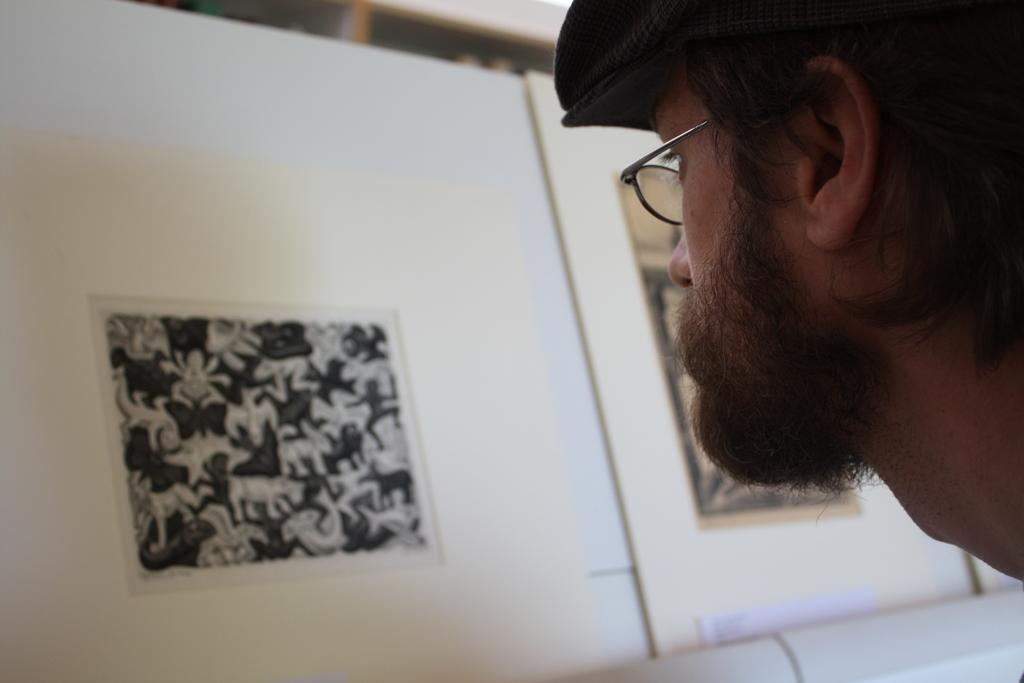Who is present on the right side of the image? There is a person on the right side of the image. What accessories is the person wearing? The person is wearing spectacles and a cap. What can be seen in the background of the image? There is a wall with posters in the background of the image. What type of suit is the person wearing in the image? There is no suit visible in the image; the person is wearing a cap and spectacles. 